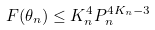<formula> <loc_0><loc_0><loc_500><loc_500>F ( \theta _ { n } ) \leq K _ { n } ^ { 4 } P _ { n } ^ { 4 K _ { n } - 3 }</formula> 